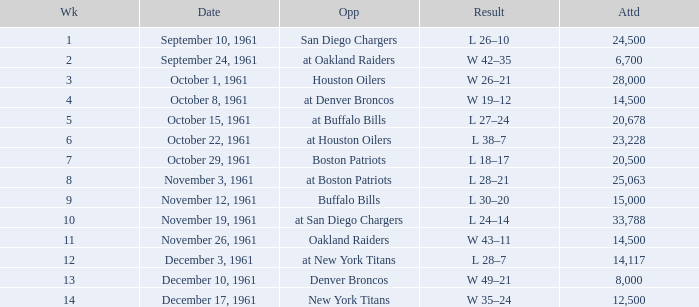What is the low week from october 15, 1961? 5.0. 